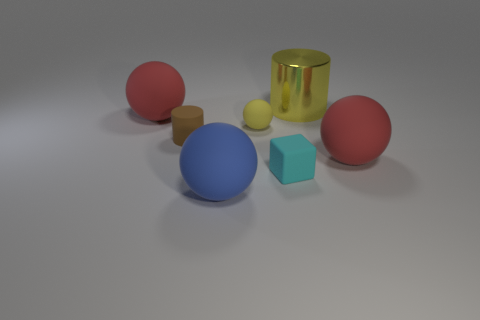Are there any other things that have the same material as the big cylinder?
Make the answer very short. No. There is a cyan thing in front of the yellow thing that is behind the big red rubber thing on the left side of the cyan block; what is its shape?
Offer a very short reply. Cube. Is the number of large metal cylinders less than the number of large cyan rubber blocks?
Your answer should be compact. No. Are there any red rubber balls behind the small rubber ball?
Make the answer very short. Yes. There is a thing that is on the right side of the tiny matte sphere and to the left of the large cylinder; what is its shape?
Offer a terse response. Cube. Is there a large red matte thing of the same shape as the cyan object?
Ensure brevity in your answer.  No. There is a red object left of the cyan matte cube; does it have the same size as the red matte thing in front of the brown matte cylinder?
Ensure brevity in your answer.  Yes. Is the number of yellow cylinders greater than the number of cyan rubber balls?
Your response must be concise. Yes. What number of big yellow cylinders are made of the same material as the cyan thing?
Keep it short and to the point. 0. Do the tiny cyan thing and the brown thing have the same shape?
Your response must be concise. No. 